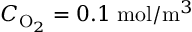<formula> <loc_0><loc_0><loc_500><loc_500>C _ { O _ { 2 } } = 0 . 1 \, m o l / m ^ { 3 }</formula> 